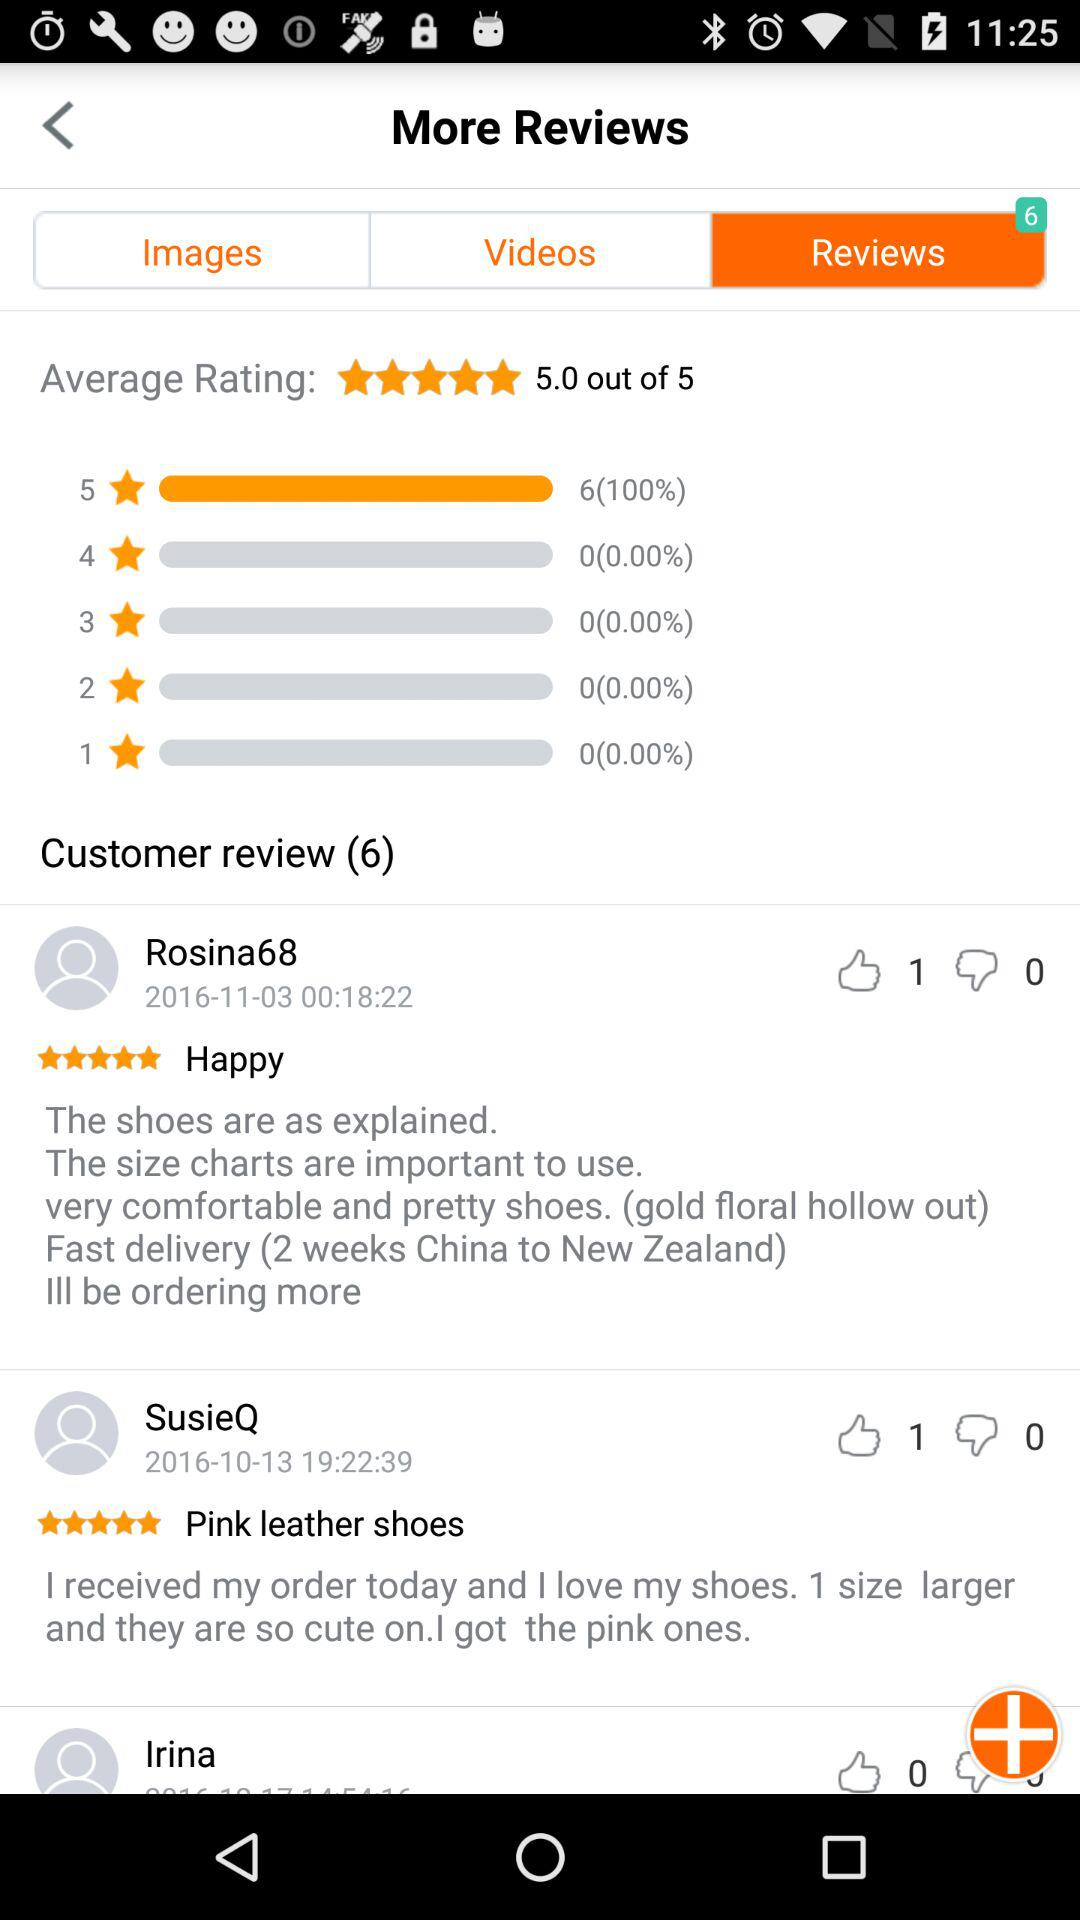How many dislikes did the review by "Rosina68" get? The number of dislikes is 0. 